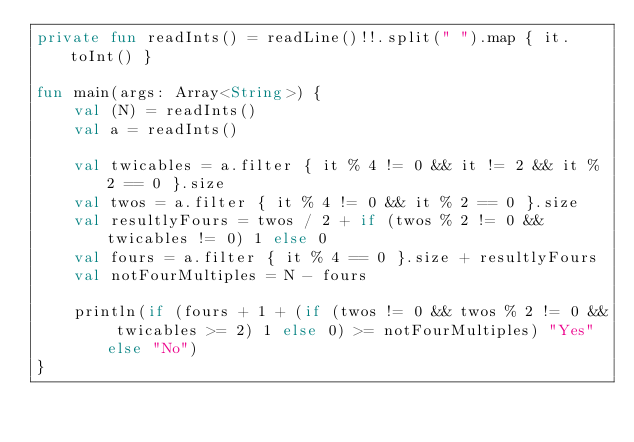<code> <loc_0><loc_0><loc_500><loc_500><_Kotlin_>private fun readInts() = readLine()!!.split(" ").map { it.toInt() }

fun main(args: Array<String>) {
    val (N) = readInts()
    val a = readInts()

    val twicables = a.filter { it % 4 != 0 && it != 2 && it % 2 == 0 }.size
    val twos = a.filter { it % 4 != 0 && it % 2 == 0 }.size
    val resultlyFours = twos / 2 + if (twos % 2 != 0 && twicables != 0) 1 else 0
    val fours = a.filter { it % 4 == 0 }.size + resultlyFours
    val notFourMultiples = N - fours

    println(if (fours + 1 + (if (twos != 0 && twos % 2 != 0 && twicables >= 2) 1 else 0) >= notFourMultiples) "Yes" else "No")
}</code> 